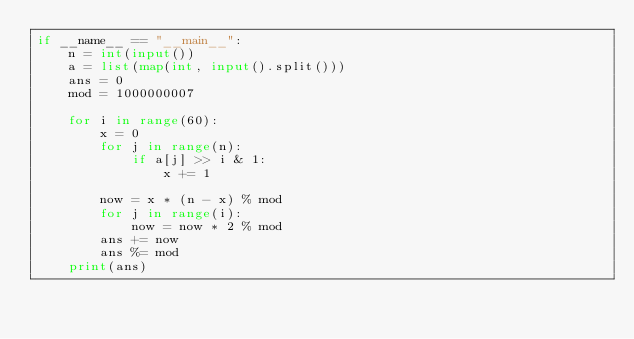<code> <loc_0><loc_0><loc_500><loc_500><_Python_>if __name__ == "__main__":
    n = int(input())
    a = list(map(int, input().split()))
    ans = 0
    mod = 1000000007

    for i in range(60):
        x = 0
        for j in range(n):
            if a[j] >> i & 1:
                x += 1
        
        now = x * (n - x) % mod
        for j in range(i):
            now = now * 2 % mod
        ans += now
        ans %= mod
    print(ans)</code> 